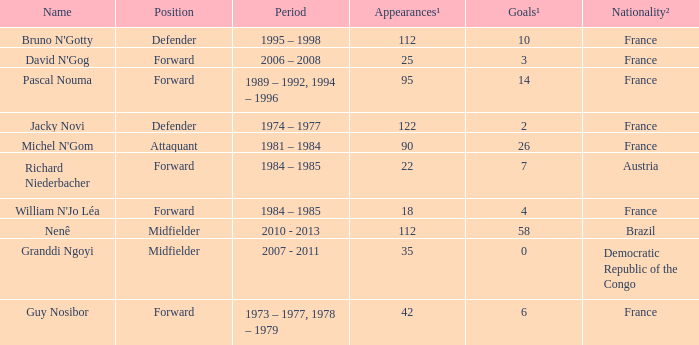Could you help me parse every detail presented in this table? {'header': ['Name', 'Position', 'Period', 'Appearances¹', 'Goals¹', 'Nationality²'], 'rows': [["Bruno N'Gotty", 'Defender', '1995 – 1998', '112', '10', 'France'], ["David N'Gog", 'Forward', '2006 – 2008', '25', '3', 'France'], ['Pascal Nouma', 'Forward', '1989 – 1992, 1994 – 1996', '95', '14', 'France'], ['Jacky Novi', 'Defender', '1974 – 1977', '122', '2', 'France'], ["Michel N'Gom", 'Attaquant', '1981 – 1984', '90', '26', 'France'], ['Richard Niederbacher', 'Forward', '1984 – 1985', '22', '7', 'Austria'], ["William N'Jo Léa", 'Forward', '1984 – 1985', '18', '4', 'France'], ['Nenê', 'Midfielder', '2010 - 2013', '112', '58', 'Brazil'], ['Granddi Ngoyi', 'Midfielder', '2007 - 2011', '35', '0', 'Democratic Republic of the Congo'], ['Guy Nosibor', 'Forward', '1973 – 1977, 1978 – 1979', '42', '6', 'France']]} How many players are from the country of Brazil? 1.0. 